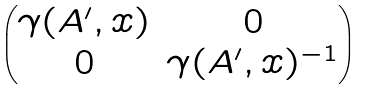Convert formula to latex. <formula><loc_0><loc_0><loc_500><loc_500>\begin{pmatrix} \gamma ( A ^ { \prime } , x ) & 0 \\ 0 & \gamma ( A ^ { \prime } , x ) ^ { - 1 } \end{pmatrix}</formula> 